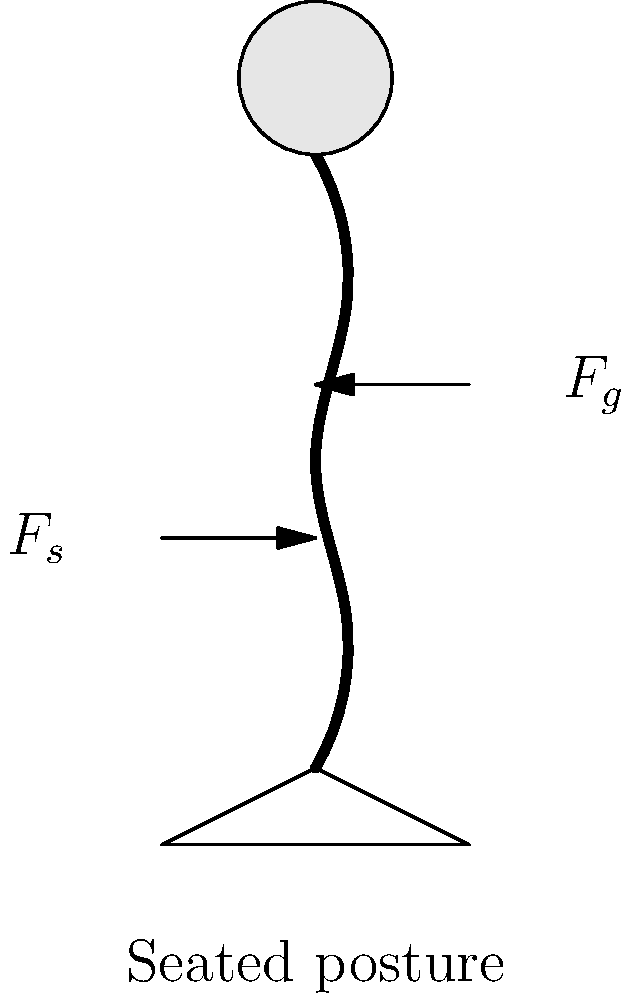During a tea ceremony, consider the biomechanical forces acting on a person's spine while sitting in an upright posture. If the gravitational force ($F_g$) acting on the upper body is 300 N and the supporting force ($F_s$) from the muscles and ligaments is 250 N, what is the net force acting on the spine, and how might this relate to the concept of balance in one's spiritual practice? To determine the net force acting on the spine, we need to consider the forces involved and their directions:

1. Gravitational force ($F_g$): This acts downward on the upper body, compressing the spine. Given as 300 N.

2. Supporting force ($F_s$): This acts upward, provided by the muscles and ligaments to maintain posture. Given as 250 N.

3. Calculate the net force:
   Net Force = $F_g - F_s$ (since they act in opposite directions)
   Net Force = 300 N - 250 N = 50 N (downward)

4. Interpretation: The positive net force indicates a downward compression on the spine.

5. Spiritual connection: This biomechanical balance can be likened to the balance sought in spiritual practices. Just as the body must find equilibrium between gravitational forces and muscular support, one's faith often involves balancing various aspects of belief and ethical considerations. The slight imbalance (50 N) could represent the constant effort required in spiritual growth, always striving for but never fully achieving perfect equilibrium.
Answer: 50 N downward 